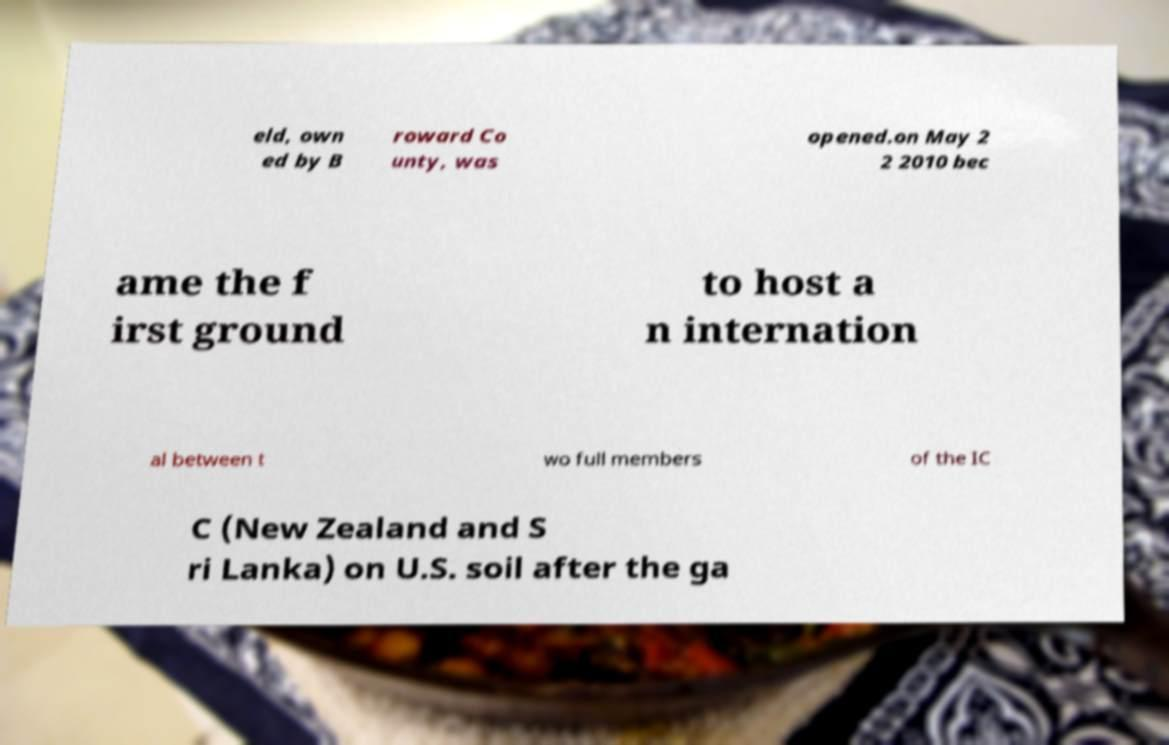What messages or text are displayed in this image? I need them in a readable, typed format. eld, own ed by B roward Co unty, was opened.on May 2 2 2010 bec ame the f irst ground to host a n internation al between t wo full members of the IC C (New Zealand and S ri Lanka) on U.S. soil after the ga 